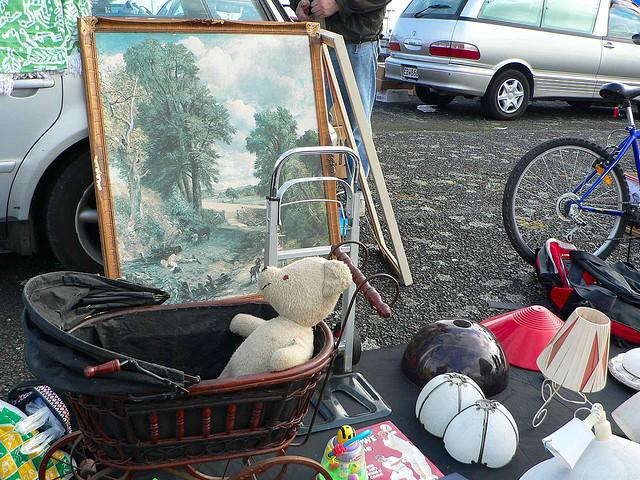This umbrellas used in which lamp? Please explain your reasoning. night. It was used to produce light at night. 